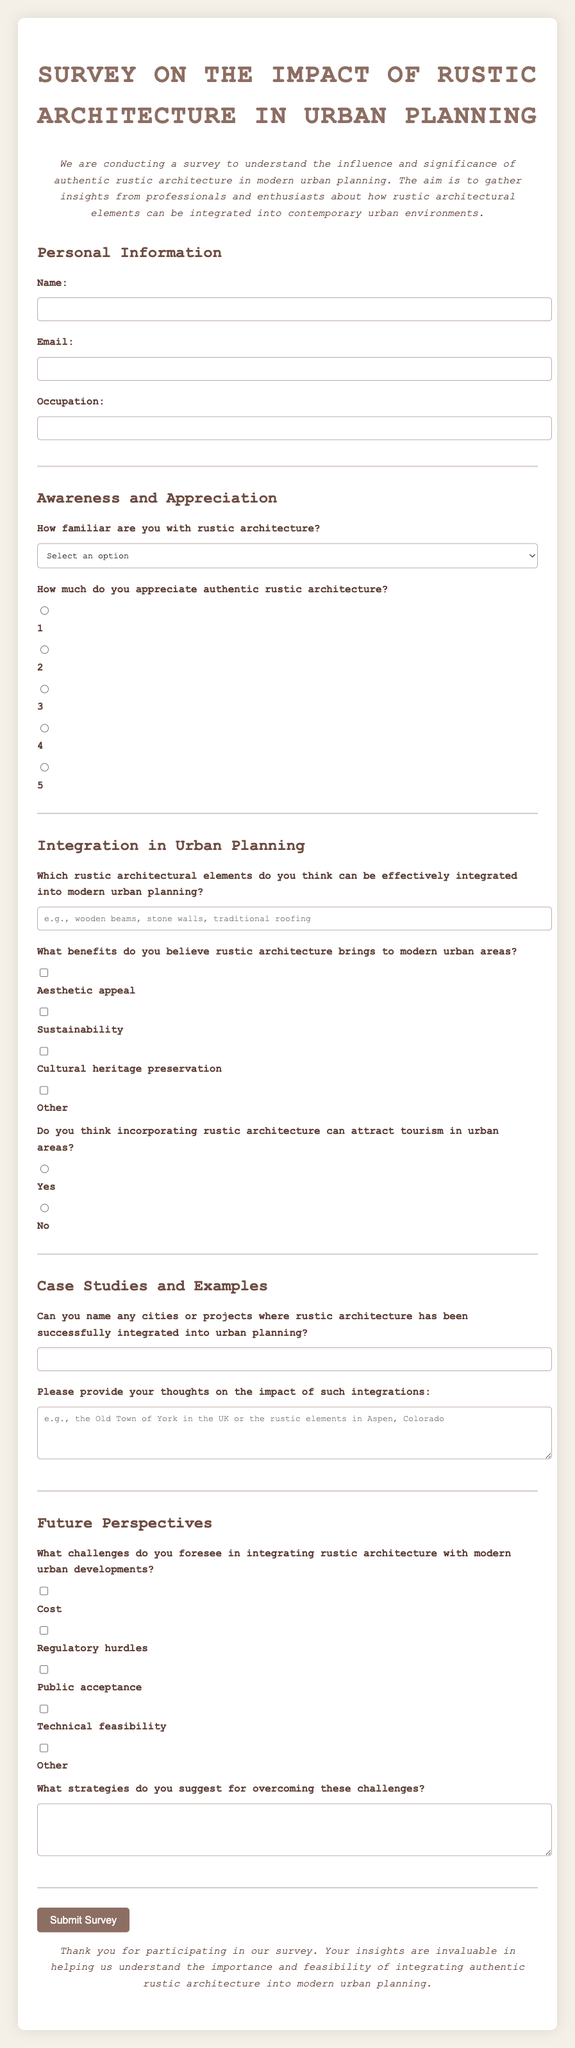What is the title of the survey? The title is found at the top of the document.
Answer: Survey on the Impact of Rustic Architecture in Urban Planning What styles of architecture are being evaluated? The survey focuses specifically on one architectural style.
Answer: Rustic architecture What are the options for familiarity with rustic architecture? The answer is found in the list of response options provided in the survey.
Answer: Very familiar, Somewhat familiar, Not very familiar, Not familiar at all What do participants rate their appreciation for rustic architecture on? The appreciation is rated using a specific scale indicated in the survey.
Answer: 1 to 5 Which benefits of rustic architecture can be selected? The options given in the survey outline various possible benefits.
Answer: Aesthetic appeal, Sustainability, Cultural heritage preservation, Other What is required in the section on integration in urban planning? This requirement is outlined in a specific area of the form focusing on urban planning.
Answer: Elements of rustic architecture What is the purpose of the survey? The purpose is stated in the introductory paragraph of the document.
Answer: To understand the influence and significance of authentic rustic architecture in modern urban planning What challenges are mentioned in the survey regarding rustic architecture? The survey lists potential obstacles that participants can identify.
Answer: Cost, Regulatory hurdles, Public acceptance, Technical feasibility, Other What strategies are requested to overcome challenges? The survey specifically prompts respondents to provide solutions for identified challenges.
Answer: Suggested strategies for overcoming challenges 